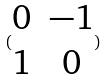Convert formula to latex. <formula><loc_0><loc_0><loc_500><loc_500>( \begin{matrix} 0 & - 1 \\ 1 & 0 \end{matrix} )</formula> 